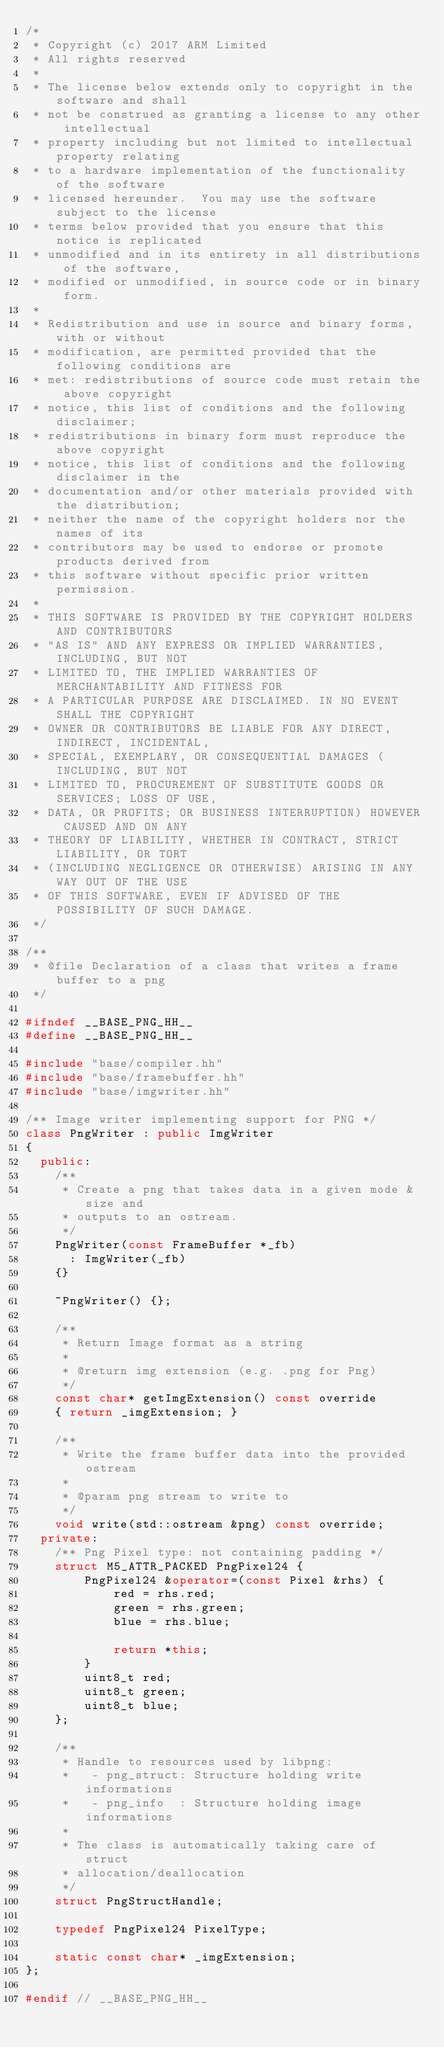Convert code to text. <code><loc_0><loc_0><loc_500><loc_500><_C++_>/*
 * Copyright (c) 2017 ARM Limited
 * All rights reserved
 *
 * The license below extends only to copyright in the software and shall
 * not be construed as granting a license to any other intellectual
 * property including but not limited to intellectual property relating
 * to a hardware implementation of the functionality of the software
 * licensed hereunder.  You may use the software subject to the license
 * terms below provided that you ensure that this notice is replicated
 * unmodified and in its entirety in all distributions of the software,
 * modified or unmodified, in source code or in binary form.
 *
 * Redistribution and use in source and binary forms, with or without
 * modification, are permitted provided that the following conditions are
 * met: redistributions of source code must retain the above copyright
 * notice, this list of conditions and the following disclaimer;
 * redistributions in binary form must reproduce the above copyright
 * notice, this list of conditions and the following disclaimer in the
 * documentation and/or other materials provided with the distribution;
 * neither the name of the copyright holders nor the names of its
 * contributors may be used to endorse or promote products derived from
 * this software without specific prior written permission.
 *
 * THIS SOFTWARE IS PROVIDED BY THE COPYRIGHT HOLDERS AND CONTRIBUTORS
 * "AS IS" AND ANY EXPRESS OR IMPLIED WARRANTIES, INCLUDING, BUT NOT
 * LIMITED TO, THE IMPLIED WARRANTIES OF MERCHANTABILITY AND FITNESS FOR
 * A PARTICULAR PURPOSE ARE DISCLAIMED. IN NO EVENT SHALL THE COPYRIGHT
 * OWNER OR CONTRIBUTORS BE LIABLE FOR ANY DIRECT, INDIRECT, INCIDENTAL,
 * SPECIAL, EXEMPLARY, OR CONSEQUENTIAL DAMAGES (INCLUDING, BUT NOT
 * LIMITED TO, PROCUREMENT OF SUBSTITUTE GOODS OR SERVICES; LOSS OF USE,
 * DATA, OR PROFITS; OR BUSINESS INTERRUPTION) HOWEVER CAUSED AND ON ANY
 * THEORY OF LIABILITY, WHETHER IN CONTRACT, STRICT LIABILITY, OR TORT
 * (INCLUDING NEGLIGENCE OR OTHERWISE) ARISING IN ANY WAY OUT OF THE USE
 * OF THIS SOFTWARE, EVEN IF ADVISED OF THE POSSIBILITY OF SUCH DAMAGE.
 */

/**
 * @file Declaration of a class that writes a frame buffer to a png
 */

#ifndef __BASE_PNG_HH__
#define __BASE_PNG_HH__

#include "base/compiler.hh"
#include "base/framebuffer.hh"
#include "base/imgwriter.hh"

/** Image writer implementing support for PNG */
class PngWriter : public ImgWriter
{
  public:
    /**
     * Create a png that takes data in a given mode & size and
     * outputs to an ostream.
     */
    PngWriter(const FrameBuffer *_fb)
      : ImgWriter(_fb)
    {}

    ~PngWriter() {};

    /**
     * Return Image format as a string
     *
     * @return img extension (e.g. .png for Png)
     */
    const char* getImgExtension() const override
    { return _imgExtension; }

    /**
     * Write the frame buffer data into the provided ostream
     *
     * @param png stream to write to
     */
    void write(std::ostream &png) const override;
  private:
    /** Png Pixel type: not containing padding */
    struct M5_ATTR_PACKED PngPixel24 {
        PngPixel24 &operator=(const Pixel &rhs) {
            red = rhs.red;
            green = rhs.green;
            blue = rhs.blue;

            return *this;
        }
        uint8_t red;
        uint8_t green;
        uint8_t blue;
    };

    /**
     * Handle to resources used by libpng:
     *   - png_struct: Structure holding write informations
     *   - png_info  : Structure holding image informations
     *
     * The class is automatically taking care of struct
     * allocation/deallocation
     */
    struct PngStructHandle;

    typedef PngPixel24 PixelType;

    static const char* _imgExtension;
};

#endif // __BASE_PNG_HH__
</code> 